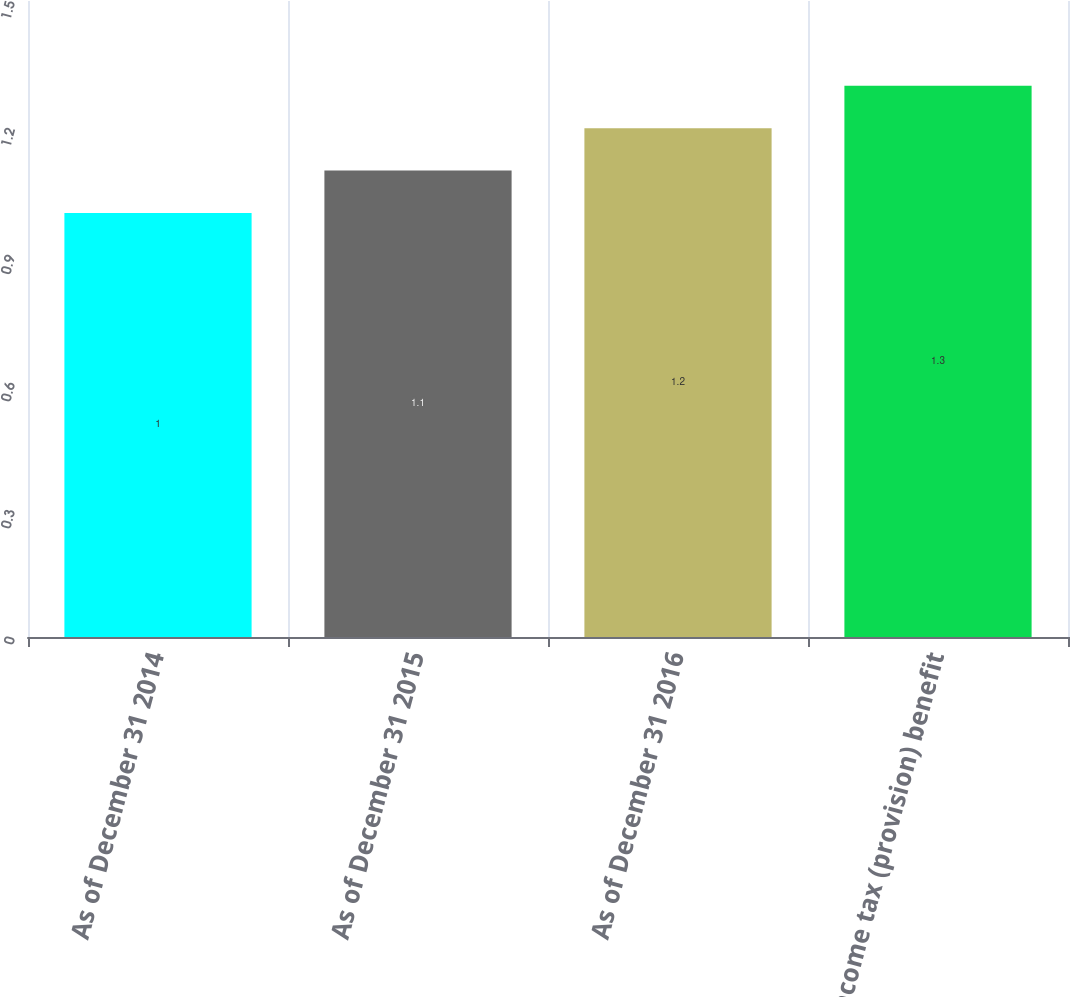Convert chart. <chart><loc_0><loc_0><loc_500><loc_500><bar_chart><fcel>As of December 31 2014<fcel>As of December 31 2015<fcel>As of December 31 2016<fcel>Income tax (provision) benefit<nl><fcel>1<fcel>1.1<fcel>1.2<fcel>1.3<nl></chart> 